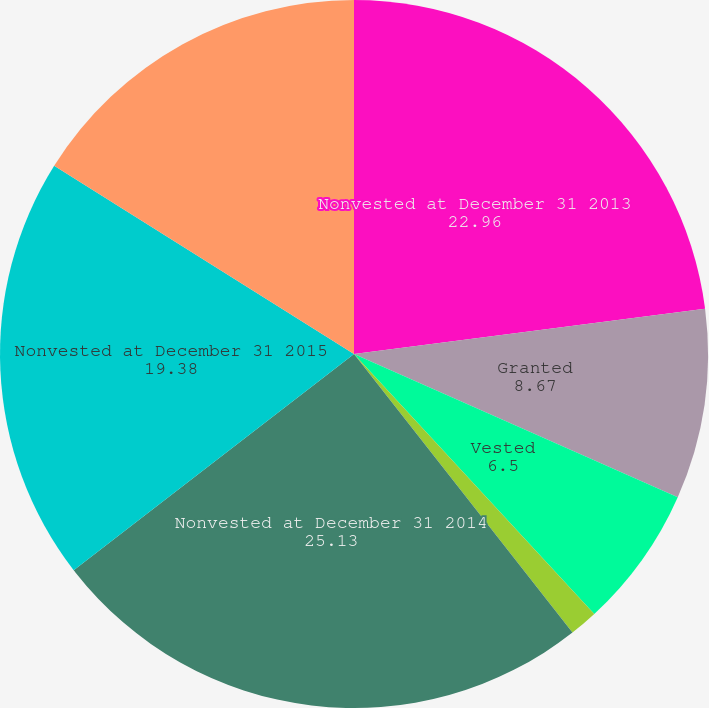Convert chart to OTSL. <chart><loc_0><loc_0><loc_500><loc_500><pie_chart><fcel>Nonvested at December 31 2013<fcel>Granted<fcel>Vested<fcel>Forfeited<fcel>Nonvested at December 31 2014<fcel>Nonvested at December 31 2015<fcel>Forfeited Nonvested at<nl><fcel>22.96%<fcel>8.67%<fcel>6.5%<fcel>1.29%<fcel>25.13%<fcel>19.38%<fcel>16.08%<nl></chart> 